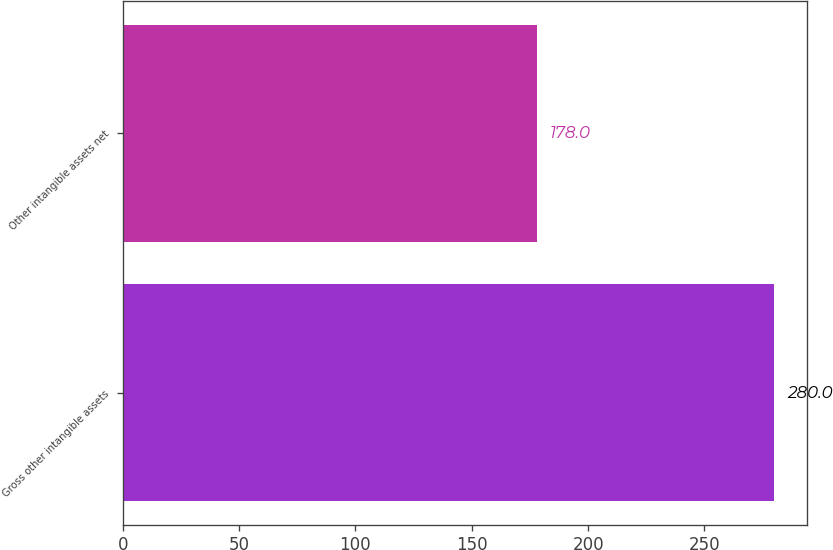<chart> <loc_0><loc_0><loc_500><loc_500><bar_chart><fcel>Gross other intangible assets<fcel>Other intangible assets net<nl><fcel>280<fcel>178<nl></chart> 